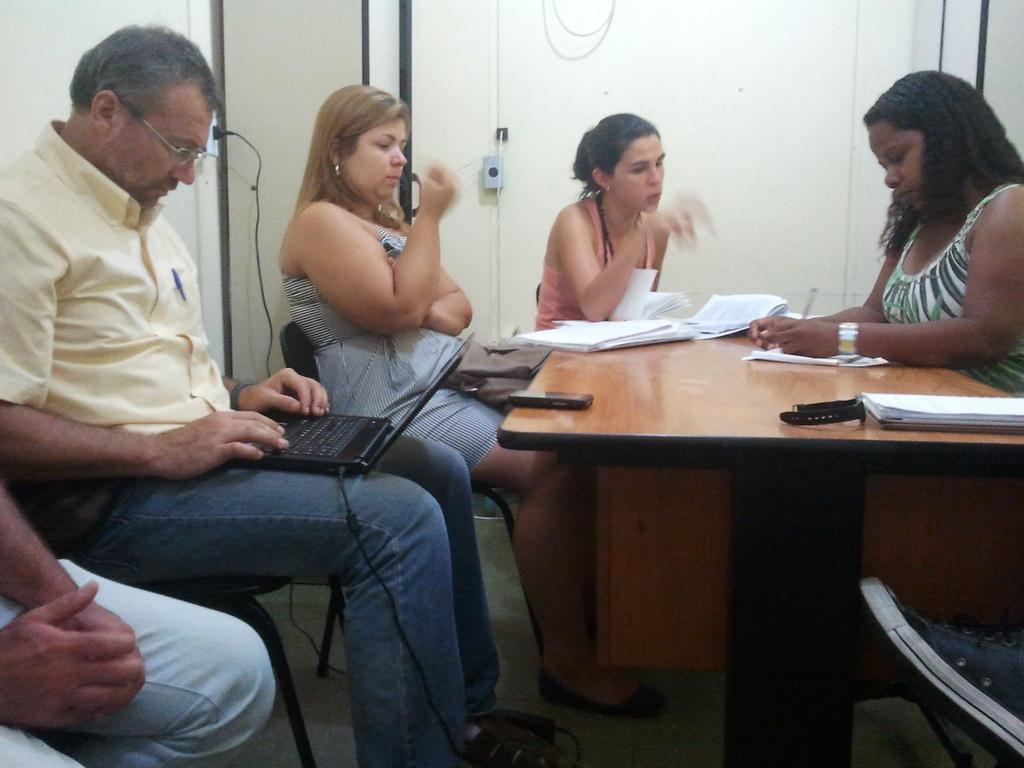How many people are in the image? There are five people in the image. What are the people doing in the image? The people are sitting on chairs. What is in front of the chairs? There is a table in front of the chairs. What items can be seen on the table? There are papers, pens, a watch, and a phone on the table. What is the man holding in the image? The man is holding a laptop in the image. What type of fan is used to cool down the people in the image? There is no fan present in the image; the people are sitting indoors. What is the purpose of the copper in the image? There is no copper present in the image, so it is not possible to determine its purpose. 